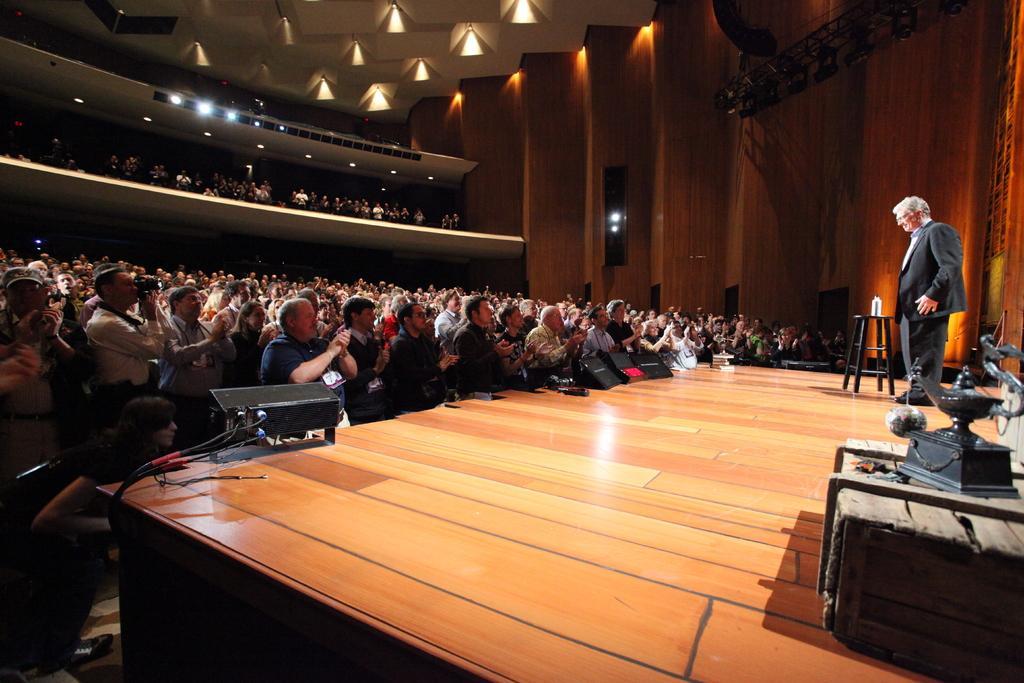Please provide a concise description of this image. In this picture we can see group of persons. This is floor and there is a man standing on the floor. Here we can see lights, stool, and a wall. 